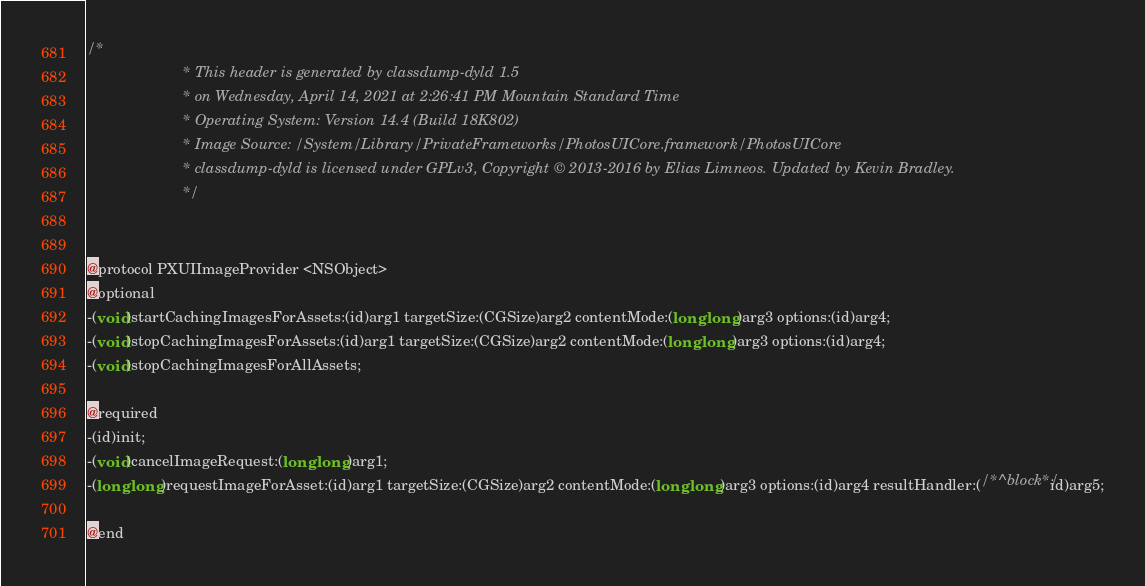<code> <loc_0><loc_0><loc_500><loc_500><_C_>/*
                       * This header is generated by classdump-dyld 1.5
                       * on Wednesday, April 14, 2021 at 2:26:41 PM Mountain Standard Time
                       * Operating System: Version 14.4 (Build 18K802)
                       * Image Source: /System/Library/PrivateFrameworks/PhotosUICore.framework/PhotosUICore
                       * classdump-dyld is licensed under GPLv3, Copyright © 2013-2016 by Elias Limneos. Updated by Kevin Bradley.
                       */


@protocol PXUIImageProvider <NSObject>
@optional
-(void)startCachingImagesForAssets:(id)arg1 targetSize:(CGSize)arg2 contentMode:(long long)arg3 options:(id)arg4;
-(void)stopCachingImagesForAssets:(id)arg1 targetSize:(CGSize)arg2 contentMode:(long long)arg3 options:(id)arg4;
-(void)stopCachingImagesForAllAssets;

@required
-(id)init;
-(void)cancelImageRequest:(long long)arg1;
-(long long)requestImageForAsset:(id)arg1 targetSize:(CGSize)arg2 contentMode:(long long)arg3 options:(id)arg4 resultHandler:(/*^block*/id)arg5;

@end

</code> 